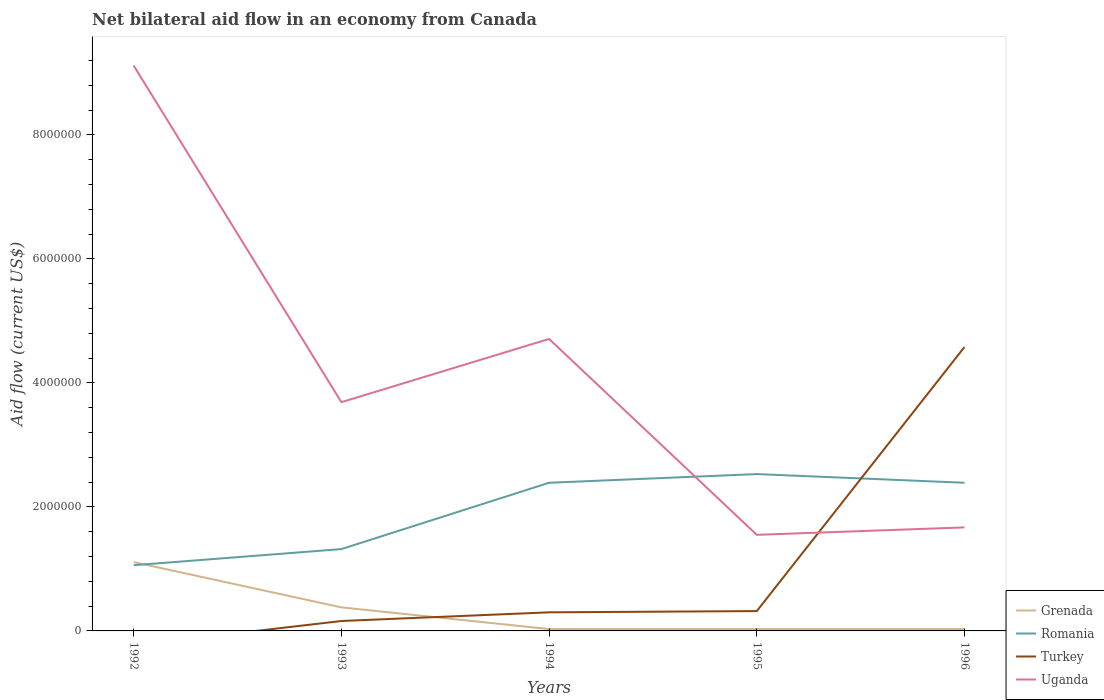How many different coloured lines are there?
Keep it short and to the point. 4. Across all years, what is the maximum net bilateral aid flow in Romania?
Provide a short and direct response. 1.06e+06. What is the total net bilateral aid flow in Romania in the graph?
Offer a terse response. -1.33e+06. What is the difference between the highest and the second highest net bilateral aid flow in Uganda?
Give a very brief answer. 7.57e+06. Is the net bilateral aid flow in Turkey strictly greater than the net bilateral aid flow in Uganda over the years?
Offer a very short reply. No. How many lines are there?
Provide a short and direct response. 4. What is the difference between two consecutive major ticks on the Y-axis?
Keep it short and to the point. 2.00e+06. Are the values on the major ticks of Y-axis written in scientific E-notation?
Make the answer very short. No. Does the graph contain grids?
Offer a very short reply. No. Where does the legend appear in the graph?
Offer a terse response. Bottom right. What is the title of the graph?
Your response must be concise. Net bilateral aid flow in an economy from Canada. Does "Myanmar" appear as one of the legend labels in the graph?
Your response must be concise. No. What is the label or title of the Y-axis?
Give a very brief answer. Aid flow (current US$). What is the Aid flow (current US$) in Grenada in 1992?
Your answer should be compact. 1.11e+06. What is the Aid flow (current US$) of Romania in 1992?
Your answer should be compact. 1.06e+06. What is the Aid flow (current US$) in Turkey in 1992?
Offer a terse response. 0. What is the Aid flow (current US$) in Uganda in 1992?
Your response must be concise. 9.12e+06. What is the Aid flow (current US$) in Romania in 1993?
Your response must be concise. 1.32e+06. What is the Aid flow (current US$) of Turkey in 1993?
Your answer should be compact. 1.60e+05. What is the Aid flow (current US$) of Uganda in 1993?
Offer a very short reply. 3.69e+06. What is the Aid flow (current US$) of Romania in 1994?
Ensure brevity in your answer.  2.39e+06. What is the Aid flow (current US$) of Turkey in 1994?
Your answer should be compact. 3.00e+05. What is the Aid flow (current US$) in Uganda in 1994?
Your response must be concise. 4.71e+06. What is the Aid flow (current US$) of Grenada in 1995?
Your response must be concise. 3.00e+04. What is the Aid flow (current US$) of Romania in 1995?
Your response must be concise. 2.53e+06. What is the Aid flow (current US$) of Turkey in 1995?
Your response must be concise. 3.20e+05. What is the Aid flow (current US$) in Uganda in 1995?
Your response must be concise. 1.55e+06. What is the Aid flow (current US$) in Grenada in 1996?
Offer a terse response. 3.00e+04. What is the Aid flow (current US$) in Romania in 1996?
Ensure brevity in your answer.  2.39e+06. What is the Aid flow (current US$) of Turkey in 1996?
Ensure brevity in your answer.  4.58e+06. What is the Aid flow (current US$) of Uganda in 1996?
Offer a terse response. 1.67e+06. Across all years, what is the maximum Aid flow (current US$) in Grenada?
Ensure brevity in your answer.  1.11e+06. Across all years, what is the maximum Aid flow (current US$) in Romania?
Provide a short and direct response. 2.53e+06. Across all years, what is the maximum Aid flow (current US$) in Turkey?
Offer a very short reply. 4.58e+06. Across all years, what is the maximum Aid flow (current US$) in Uganda?
Offer a very short reply. 9.12e+06. Across all years, what is the minimum Aid flow (current US$) in Grenada?
Keep it short and to the point. 3.00e+04. Across all years, what is the minimum Aid flow (current US$) in Romania?
Provide a succinct answer. 1.06e+06. Across all years, what is the minimum Aid flow (current US$) in Uganda?
Ensure brevity in your answer.  1.55e+06. What is the total Aid flow (current US$) in Grenada in the graph?
Offer a very short reply. 1.58e+06. What is the total Aid flow (current US$) in Romania in the graph?
Your answer should be very brief. 9.69e+06. What is the total Aid flow (current US$) in Turkey in the graph?
Keep it short and to the point. 5.36e+06. What is the total Aid flow (current US$) in Uganda in the graph?
Provide a succinct answer. 2.07e+07. What is the difference between the Aid flow (current US$) in Grenada in 1992 and that in 1993?
Keep it short and to the point. 7.30e+05. What is the difference between the Aid flow (current US$) in Uganda in 1992 and that in 1993?
Give a very brief answer. 5.43e+06. What is the difference between the Aid flow (current US$) in Grenada in 1992 and that in 1994?
Your answer should be very brief. 1.08e+06. What is the difference between the Aid flow (current US$) in Romania in 1992 and that in 1994?
Your answer should be very brief. -1.33e+06. What is the difference between the Aid flow (current US$) in Uganda in 1992 and that in 1994?
Your answer should be very brief. 4.41e+06. What is the difference between the Aid flow (current US$) in Grenada in 1992 and that in 1995?
Ensure brevity in your answer.  1.08e+06. What is the difference between the Aid flow (current US$) of Romania in 1992 and that in 1995?
Your answer should be compact. -1.47e+06. What is the difference between the Aid flow (current US$) of Uganda in 1992 and that in 1995?
Offer a terse response. 7.57e+06. What is the difference between the Aid flow (current US$) of Grenada in 1992 and that in 1996?
Give a very brief answer. 1.08e+06. What is the difference between the Aid flow (current US$) of Romania in 1992 and that in 1996?
Offer a very short reply. -1.33e+06. What is the difference between the Aid flow (current US$) of Uganda in 1992 and that in 1996?
Your answer should be compact. 7.45e+06. What is the difference between the Aid flow (current US$) of Romania in 1993 and that in 1994?
Offer a terse response. -1.07e+06. What is the difference between the Aid flow (current US$) in Turkey in 1993 and that in 1994?
Ensure brevity in your answer.  -1.40e+05. What is the difference between the Aid flow (current US$) in Uganda in 1993 and that in 1994?
Make the answer very short. -1.02e+06. What is the difference between the Aid flow (current US$) of Grenada in 1993 and that in 1995?
Make the answer very short. 3.50e+05. What is the difference between the Aid flow (current US$) in Romania in 1993 and that in 1995?
Offer a very short reply. -1.21e+06. What is the difference between the Aid flow (current US$) of Turkey in 1993 and that in 1995?
Your answer should be compact. -1.60e+05. What is the difference between the Aid flow (current US$) in Uganda in 1993 and that in 1995?
Your answer should be compact. 2.14e+06. What is the difference between the Aid flow (current US$) of Grenada in 1993 and that in 1996?
Provide a short and direct response. 3.50e+05. What is the difference between the Aid flow (current US$) in Romania in 1993 and that in 1996?
Your answer should be very brief. -1.07e+06. What is the difference between the Aid flow (current US$) of Turkey in 1993 and that in 1996?
Give a very brief answer. -4.42e+06. What is the difference between the Aid flow (current US$) of Uganda in 1993 and that in 1996?
Offer a terse response. 2.02e+06. What is the difference between the Aid flow (current US$) in Grenada in 1994 and that in 1995?
Your response must be concise. 0. What is the difference between the Aid flow (current US$) in Turkey in 1994 and that in 1995?
Your answer should be compact. -2.00e+04. What is the difference between the Aid flow (current US$) in Uganda in 1994 and that in 1995?
Provide a succinct answer. 3.16e+06. What is the difference between the Aid flow (current US$) of Romania in 1994 and that in 1996?
Your answer should be compact. 0. What is the difference between the Aid flow (current US$) in Turkey in 1994 and that in 1996?
Make the answer very short. -4.28e+06. What is the difference between the Aid flow (current US$) in Uganda in 1994 and that in 1996?
Your answer should be compact. 3.04e+06. What is the difference between the Aid flow (current US$) of Romania in 1995 and that in 1996?
Your answer should be compact. 1.40e+05. What is the difference between the Aid flow (current US$) of Turkey in 1995 and that in 1996?
Give a very brief answer. -4.26e+06. What is the difference between the Aid flow (current US$) of Uganda in 1995 and that in 1996?
Ensure brevity in your answer.  -1.20e+05. What is the difference between the Aid flow (current US$) in Grenada in 1992 and the Aid flow (current US$) in Turkey in 1993?
Your answer should be very brief. 9.50e+05. What is the difference between the Aid flow (current US$) in Grenada in 1992 and the Aid flow (current US$) in Uganda in 1993?
Keep it short and to the point. -2.58e+06. What is the difference between the Aid flow (current US$) of Romania in 1992 and the Aid flow (current US$) of Turkey in 1993?
Offer a very short reply. 9.00e+05. What is the difference between the Aid flow (current US$) of Romania in 1992 and the Aid flow (current US$) of Uganda in 1993?
Provide a succinct answer. -2.63e+06. What is the difference between the Aid flow (current US$) in Grenada in 1992 and the Aid flow (current US$) in Romania in 1994?
Your answer should be very brief. -1.28e+06. What is the difference between the Aid flow (current US$) in Grenada in 1992 and the Aid flow (current US$) in Turkey in 1994?
Offer a very short reply. 8.10e+05. What is the difference between the Aid flow (current US$) of Grenada in 1992 and the Aid flow (current US$) of Uganda in 1994?
Keep it short and to the point. -3.60e+06. What is the difference between the Aid flow (current US$) of Romania in 1992 and the Aid flow (current US$) of Turkey in 1994?
Provide a succinct answer. 7.60e+05. What is the difference between the Aid flow (current US$) in Romania in 1992 and the Aid flow (current US$) in Uganda in 1994?
Offer a very short reply. -3.65e+06. What is the difference between the Aid flow (current US$) in Grenada in 1992 and the Aid flow (current US$) in Romania in 1995?
Your answer should be very brief. -1.42e+06. What is the difference between the Aid flow (current US$) in Grenada in 1992 and the Aid flow (current US$) in Turkey in 1995?
Offer a terse response. 7.90e+05. What is the difference between the Aid flow (current US$) of Grenada in 1992 and the Aid flow (current US$) of Uganda in 1995?
Give a very brief answer. -4.40e+05. What is the difference between the Aid flow (current US$) in Romania in 1992 and the Aid flow (current US$) in Turkey in 1995?
Your answer should be very brief. 7.40e+05. What is the difference between the Aid flow (current US$) in Romania in 1992 and the Aid flow (current US$) in Uganda in 1995?
Ensure brevity in your answer.  -4.90e+05. What is the difference between the Aid flow (current US$) of Grenada in 1992 and the Aid flow (current US$) of Romania in 1996?
Provide a succinct answer. -1.28e+06. What is the difference between the Aid flow (current US$) of Grenada in 1992 and the Aid flow (current US$) of Turkey in 1996?
Offer a terse response. -3.47e+06. What is the difference between the Aid flow (current US$) in Grenada in 1992 and the Aid flow (current US$) in Uganda in 1996?
Your response must be concise. -5.60e+05. What is the difference between the Aid flow (current US$) in Romania in 1992 and the Aid flow (current US$) in Turkey in 1996?
Give a very brief answer. -3.52e+06. What is the difference between the Aid flow (current US$) in Romania in 1992 and the Aid flow (current US$) in Uganda in 1996?
Ensure brevity in your answer.  -6.10e+05. What is the difference between the Aid flow (current US$) in Grenada in 1993 and the Aid flow (current US$) in Romania in 1994?
Your response must be concise. -2.01e+06. What is the difference between the Aid flow (current US$) in Grenada in 1993 and the Aid flow (current US$) in Turkey in 1994?
Your answer should be very brief. 8.00e+04. What is the difference between the Aid flow (current US$) of Grenada in 1993 and the Aid flow (current US$) of Uganda in 1994?
Ensure brevity in your answer.  -4.33e+06. What is the difference between the Aid flow (current US$) of Romania in 1993 and the Aid flow (current US$) of Turkey in 1994?
Offer a terse response. 1.02e+06. What is the difference between the Aid flow (current US$) in Romania in 1993 and the Aid flow (current US$) in Uganda in 1994?
Provide a succinct answer. -3.39e+06. What is the difference between the Aid flow (current US$) of Turkey in 1993 and the Aid flow (current US$) of Uganda in 1994?
Make the answer very short. -4.55e+06. What is the difference between the Aid flow (current US$) in Grenada in 1993 and the Aid flow (current US$) in Romania in 1995?
Offer a very short reply. -2.15e+06. What is the difference between the Aid flow (current US$) of Grenada in 1993 and the Aid flow (current US$) of Turkey in 1995?
Give a very brief answer. 6.00e+04. What is the difference between the Aid flow (current US$) in Grenada in 1993 and the Aid flow (current US$) in Uganda in 1995?
Offer a terse response. -1.17e+06. What is the difference between the Aid flow (current US$) in Turkey in 1993 and the Aid flow (current US$) in Uganda in 1995?
Make the answer very short. -1.39e+06. What is the difference between the Aid flow (current US$) of Grenada in 1993 and the Aid flow (current US$) of Romania in 1996?
Give a very brief answer. -2.01e+06. What is the difference between the Aid flow (current US$) of Grenada in 1993 and the Aid flow (current US$) of Turkey in 1996?
Ensure brevity in your answer.  -4.20e+06. What is the difference between the Aid flow (current US$) of Grenada in 1993 and the Aid flow (current US$) of Uganda in 1996?
Your answer should be compact. -1.29e+06. What is the difference between the Aid flow (current US$) in Romania in 1993 and the Aid flow (current US$) in Turkey in 1996?
Give a very brief answer. -3.26e+06. What is the difference between the Aid flow (current US$) of Romania in 1993 and the Aid flow (current US$) of Uganda in 1996?
Make the answer very short. -3.50e+05. What is the difference between the Aid flow (current US$) of Turkey in 1993 and the Aid flow (current US$) of Uganda in 1996?
Offer a terse response. -1.51e+06. What is the difference between the Aid flow (current US$) of Grenada in 1994 and the Aid flow (current US$) of Romania in 1995?
Provide a succinct answer. -2.50e+06. What is the difference between the Aid flow (current US$) of Grenada in 1994 and the Aid flow (current US$) of Turkey in 1995?
Your response must be concise. -2.90e+05. What is the difference between the Aid flow (current US$) of Grenada in 1994 and the Aid flow (current US$) of Uganda in 1995?
Your response must be concise. -1.52e+06. What is the difference between the Aid flow (current US$) in Romania in 1994 and the Aid flow (current US$) in Turkey in 1995?
Your answer should be compact. 2.07e+06. What is the difference between the Aid flow (current US$) in Romania in 1994 and the Aid flow (current US$) in Uganda in 1995?
Offer a terse response. 8.40e+05. What is the difference between the Aid flow (current US$) of Turkey in 1994 and the Aid flow (current US$) of Uganda in 1995?
Your answer should be compact. -1.25e+06. What is the difference between the Aid flow (current US$) of Grenada in 1994 and the Aid flow (current US$) of Romania in 1996?
Your answer should be compact. -2.36e+06. What is the difference between the Aid flow (current US$) of Grenada in 1994 and the Aid flow (current US$) of Turkey in 1996?
Offer a terse response. -4.55e+06. What is the difference between the Aid flow (current US$) in Grenada in 1994 and the Aid flow (current US$) in Uganda in 1996?
Your answer should be compact. -1.64e+06. What is the difference between the Aid flow (current US$) of Romania in 1994 and the Aid flow (current US$) of Turkey in 1996?
Keep it short and to the point. -2.19e+06. What is the difference between the Aid flow (current US$) of Romania in 1994 and the Aid flow (current US$) of Uganda in 1996?
Give a very brief answer. 7.20e+05. What is the difference between the Aid flow (current US$) of Turkey in 1994 and the Aid flow (current US$) of Uganda in 1996?
Provide a succinct answer. -1.37e+06. What is the difference between the Aid flow (current US$) of Grenada in 1995 and the Aid flow (current US$) of Romania in 1996?
Keep it short and to the point. -2.36e+06. What is the difference between the Aid flow (current US$) of Grenada in 1995 and the Aid flow (current US$) of Turkey in 1996?
Keep it short and to the point. -4.55e+06. What is the difference between the Aid flow (current US$) in Grenada in 1995 and the Aid flow (current US$) in Uganda in 1996?
Offer a very short reply. -1.64e+06. What is the difference between the Aid flow (current US$) in Romania in 1995 and the Aid flow (current US$) in Turkey in 1996?
Provide a short and direct response. -2.05e+06. What is the difference between the Aid flow (current US$) in Romania in 1995 and the Aid flow (current US$) in Uganda in 1996?
Make the answer very short. 8.60e+05. What is the difference between the Aid flow (current US$) in Turkey in 1995 and the Aid flow (current US$) in Uganda in 1996?
Your response must be concise. -1.35e+06. What is the average Aid flow (current US$) of Grenada per year?
Your answer should be very brief. 3.16e+05. What is the average Aid flow (current US$) in Romania per year?
Make the answer very short. 1.94e+06. What is the average Aid flow (current US$) of Turkey per year?
Give a very brief answer. 1.07e+06. What is the average Aid flow (current US$) in Uganda per year?
Give a very brief answer. 4.15e+06. In the year 1992, what is the difference between the Aid flow (current US$) of Grenada and Aid flow (current US$) of Uganda?
Offer a terse response. -8.01e+06. In the year 1992, what is the difference between the Aid flow (current US$) of Romania and Aid flow (current US$) of Uganda?
Provide a short and direct response. -8.06e+06. In the year 1993, what is the difference between the Aid flow (current US$) of Grenada and Aid flow (current US$) of Romania?
Provide a short and direct response. -9.40e+05. In the year 1993, what is the difference between the Aid flow (current US$) of Grenada and Aid flow (current US$) of Uganda?
Offer a terse response. -3.31e+06. In the year 1993, what is the difference between the Aid flow (current US$) in Romania and Aid flow (current US$) in Turkey?
Your answer should be very brief. 1.16e+06. In the year 1993, what is the difference between the Aid flow (current US$) in Romania and Aid flow (current US$) in Uganda?
Your response must be concise. -2.37e+06. In the year 1993, what is the difference between the Aid flow (current US$) of Turkey and Aid flow (current US$) of Uganda?
Ensure brevity in your answer.  -3.53e+06. In the year 1994, what is the difference between the Aid flow (current US$) in Grenada and Aid flow (current US$) in Romania?
Your answer should be very brief. -2.36e+06. In the year 1994, what is the difference between the Aid flow (current US$) in Grenada and Aid flow (current US$) in Turkey?
Provide a succinct answer. -2.70e+05. In the year 1994, what is the difference between the Aid flow (current US$) in Grenada and Aid flow (current US$) in Uganda?
Offer a terse response. -4.68e+06. In the year 1994, what is the difference between the Aid flow (current US$) of Romania and Aid flow (current US$) of Turkey?
Keep it short and to the point. 2.09e+06. In the year 1994, what is the difference between the Aid flow (current US$) in Romania and Aid flow (current US$) in Uganda?
Ensure brevity in your answer.  -2.32e+06. In the year 1994, what is the difference between the Aid flow (current US$) of Turkey and Aid flow (current US$) of Uganda?
Provide a short and direct response. -4.41e+06. In the year 1995, what is the difference between the Aid flow (current US$) of Grenada and Aid flow (current US$) of Romania?
Ensure brevity in your answer.  -2.50e+06. In the year 1995, what is the difference between the Aid flow (current US$) in Grenada and Aid flow (current US$) in Turkey?
Provide a succinct answer. -2.90e+05. In the year 1995, what is the difference between the Aid flow (current US$) of Grenada and Aid flow (current US$) of Uganda?
Your answer should be compact. -1.52e+06. In the year 1995, what is the difference between the Aid flow (current US$) of Romania and Aid flow (current US$) of Turkey?
Offer a very short reply. 2.21e+06. In the year 1995, what is the difference between the Aid flow (current US$) of Romania and Aid flow (current US$) of Uganda?
Offer a terse response. 9.80e+05. In the year 1995, what is the difference between the Aid flow (current US$) of Turkey and Aid flow (current US$) of Uganda?
Offer a very short reply. -1.23e+06. In the year 1996, what is the difference between the Aid flow (current US$) in Grenada and Aid flow (current US$) in Romania?
Provide a succinct answer. -2.36e+06. In the year 1996, what is the difference between the Aid flow (current US$) in Grenada and Aid flow (current US$) in Turkey?
Your answer should be very brief. -4.55e+06. In the year 1996, what is the difference between the Aid flow (current US$) of Grenada and Aid flow (current US$) of Uganda?
Make the answer very short. -1.64e+06. In the year 1996, what is the difference between the Aid flow (current US$) in Romania and Aid flow (current US$) in Turkey?
Make the answer very short. -2.19e+06. In the year 1996, what is the difference between the Aid flow (current US$) of Romania and Aid flow (current US$) of Uganda?
Your answer should be very brief. 7.20e+05. In the year 1996, what is the difference between the Aid flow (current US$) in Turkey and Aid flow (current US$) in Uganda?
Your response must be concise. 2.91e+06. What is the ratio of the Aid flow (current US$) in Grenada in 1992 to that in 1993?
Make the answer very short. 2.92. What is the ratio of the Aid flow (current US$) of Romania in 1992 to that in 1993?
Keep it short and to the point. 0.8. What is the ratio of the Aid flow (current US$) in Uganda in 1992 to that in 1993?
Provide a succinct answer. 2.47. What is the ratio of the Aid flow (current US$) of Grenada in 1992 to that in 1994?
Provide a short and direct response. 37. What is the ratio of the Aid flow (current US$) in Romania in 1992 to that in 1994?
Keep it short and to the point. 0.44. What is the ratio of the Aid flow (current US$) of Uganda in 1992 to that in 1994?
Offer a terse response. 1.94. What is the ratio of the Aid flow (current US$) of Romania in 1992 to that in 1995?
Provide a short and direct response. 0.42. What is the ratio of the Aid flow (current US$) of Uganda in 1992 to that in 1995?
Offer a very short reply. 5.88. What is the ratio of the Aid flow (current US$) of Grenada in 1992 to that in 1996?
Provide a short and direct response. 37. What is the ratio of the Aid flow (current US$) in Romania in 1992 to that in 1996?
Your response must be concise. 0.44. What is the ratio of the Aid flow (current US$) of Uganda in 1992 to that in 1996?
Keep it short and to the point. 5.46. What is the ratio of the Aid flow (current US$) in Grenada in 1993 to that in 1994?
Your answer should be compact. 12.67. What is the ratio of the Aid flow (current US$) of Romania in 1993 to that in 1994?
Provide a succinct answer. 0.55. What is the ratio of the Aid flow (current US$) in Turkey in 1993 to that in 1994?
Provide a succinct answer. 0.53. What is the ratio of the Aid flow (current US$) of Uganda in 1993 to that in 1994?
Make the answer very short. 0.78. What is the ratio of the Aid flow (current US$) of Grenada in 1993 to that in 1995?
Keep it short and to the point. 12.67. What is the ratio of the Aid flow (current US$) in Romania in 1993 to that in 1995?
Keep it short and to the point. 0.52. What is the ratio of the Aid flow (current US$) of Turkey in 1993 to that in 1995?
Your answer should be very brief. 0.5. What is the ratio of the Aid flow (current US$) of Uganda in 1993 to that in 1995?
Offer a very short reply. 2.38. What is the ratio of the Aid flow (current US$) of Grenada in 1993 to that in 1996?
Your answer should be very brief. 12.67. What is the ratio of the Aid flow (current US$) in Romania in 1993 to that in 1996?
Give a very brief answer. 0.55. What is the ratio of the Aid flow (current US$) in Turkey in 1993 to that in 1996?
Keep it short and to the point. 0.03. What is the ratio of the Aid flow (current US$) of Uganda in 1993 to that in 1996?
Your answer should be very brief. 2.21. What is the ratio of the Aid flow (current US$) of Romania in 1994 to that in 1995?
Give a very brief answer. 0.94. What is the ratio of the Aid flow (current US$) in Turkey in 1994 to that in 1995?
Provide a succinct answer. 0.94. What is the ratio of the Aid flow (current US$) of Uganda in 1994 to that in 1995?
Offer a terse response. 3.04. What is the ratio of the Aid flow (current US$) in Romania in 1994 to that in 1996?
Make the answer very short. 1. What is the ratio of the Aid flow (current US$) of Turkey in 1994 to that in 1996?
Your answer should be very brief. 0.07. What is the ratio of the Aid flow (current US$) in Uganda in 1994 to that in 1996?
Offer a very short reply. 2.82. What is the ratio of the Aid flow (current US$) of Grenada in 1995 to that in 1996?
Provide a succinct answer. 1. What is the ratio of the Aid flow (current US$) in Romania in 1995 to that in 1996?
Your answer should be very brief. 1.06. What is the ratio of the Aid flow (current US$) of Turkey in 1995 to that in 1996?
Make the answer very short. 0.07. What is the ratio of the Aid flow (current US$) in Uganda in 1995 to that in 1996?
Make the answer very short. 0.93. What is the difference between the highest and the second highest Aid flow (current US$) in Grenada?
Offer a terse response. 7.30e+05. What is the difference between the highest and the second highest Aid flow (current US$) in Romania?
Ensure brevity in your answer.  1.40e+05. What is the difference between the highest and the second highest Aid flow (current US$) in Turkey?
Give a very brief answer. 4.26e+06. What is the difference between the highest and the second highest Aid flow (current US$) of Uganda?
Provide a succinct answer. 4.41e+06. What is the difference between the highest and the lowest Aid flow (current US$) of Grenada?
Your answer should be compact. 1.08e+06. What is the difference between the highest and the lowest Aid flow (current US$) of Romania?
Give a very brief answer. 1.47e+06. What is the difference between the highest and the lowest Aid flow (current US$) of Turkey?
Your answer should be compact. 4.58e+06. What is the difference between the highest and the lowest Aid flow (current US$) in Uganda?
Offer a very short reply. 7.57e+06. 